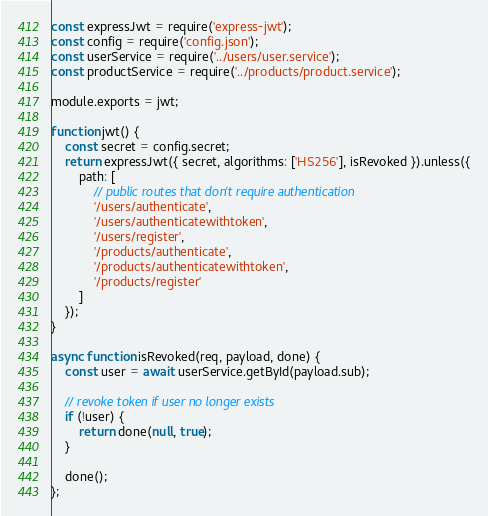<code> <loc_0><loc_0><loc_500><loc_500><_JavaScript_>const expressJwt = require('express-jwt');
const config = require('config.json');
const userService = require('../users/user.service');
const productService = require('../products/product.service');

module.exports = jwt;

function jwt() {
    const secret = config.secret;
    return expressJwt({ secret, algorithms: ['HS256'], isRevoked }).unless({
        path: [
            // public routes that don't require authentication
            '/users/authenticate',
            '/users/authenticatewithtoken',
            '/users/register',
            '/products/authenticate',
            '/products/authenticatewithtoken',
            '/products/register'
        ]
    });
}

async function isRevoked(req, payload, done) {
    const user = await userService.getById(payload.sub);

    // revoke token if user no longer exists
    if (!user) {
        return done(null, true);
    }

    done();
};</code> 